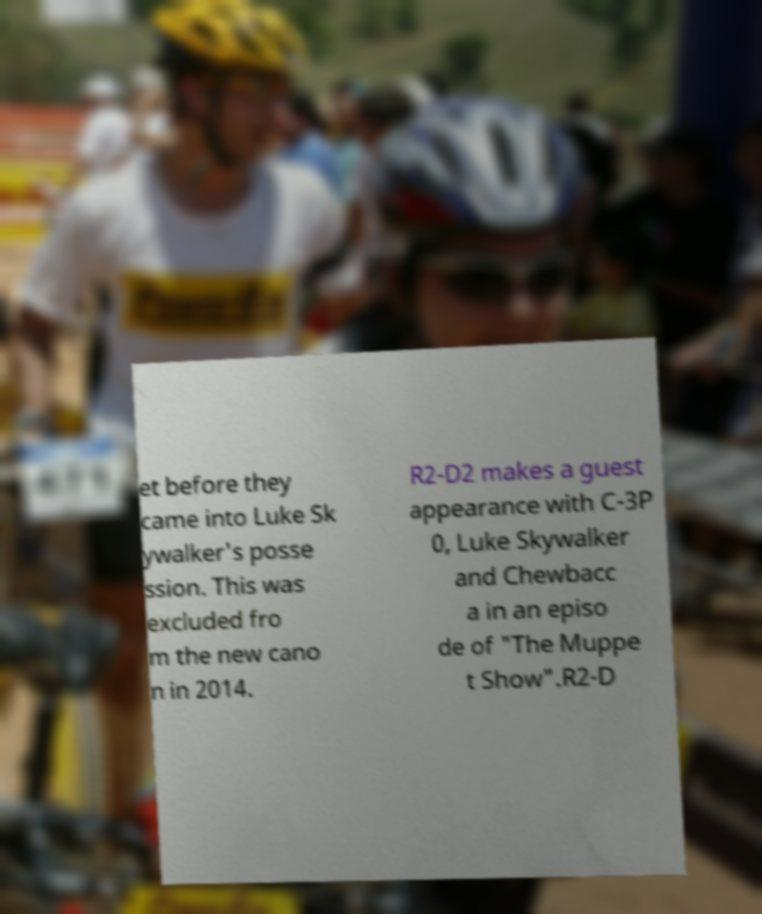Can you accurately transcribe the text from the provided image for me? et before they came into Luke Sk ywalker's posse ssion. This was excluded fro m the new cano n in 2014. R2-D2 makes a guest appearance with C-3P 0, Luke Skywalker and Chewbacc a in an episo de of "The Muppe t Show".R2-D 